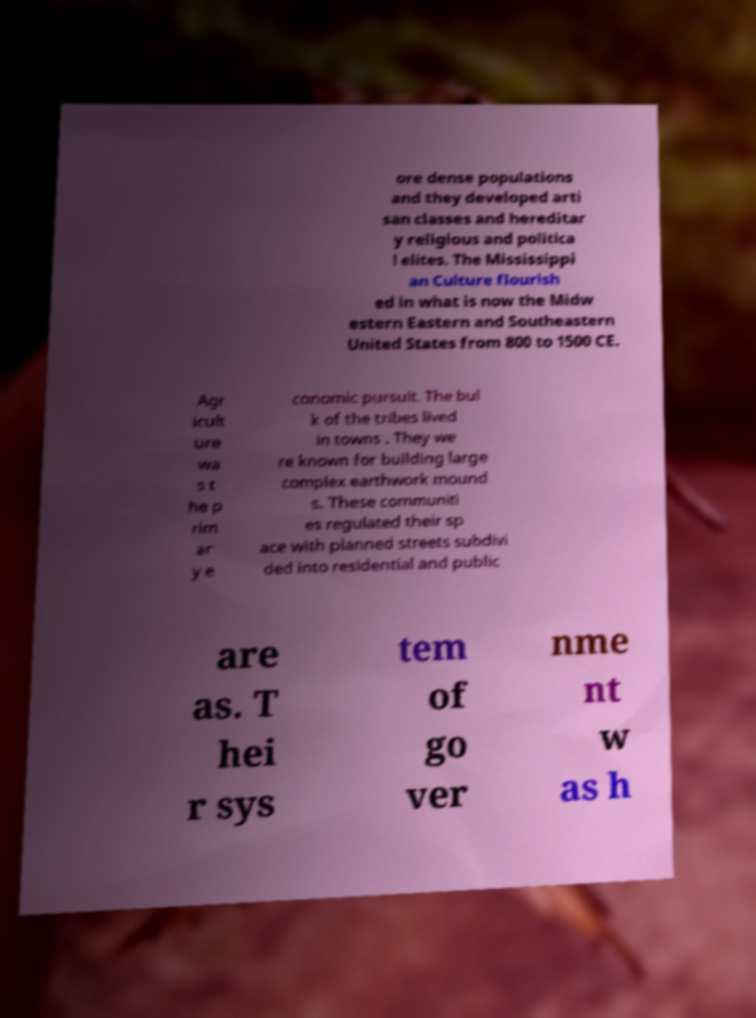Could you assist in decoding the text presented in this image and type it out clearly? ore dense populations and they developed arti san classes and hereditar y religious and politica l elites. The Mississippi an Culture flourish ed in what is now the Midw estern Eastern and Southeastern United States from 800 to 1500 CE. Agr icult ure wa s t he p rim ar y e conomic pursuit. The bul k of the tribes lived in towns . They we re known for building large complex earthwork mound s. These communiti es regulated their sp ace with planned streets subdivi ded into residential and public are as. T hei r sys tem of go ver nme nt w as h 